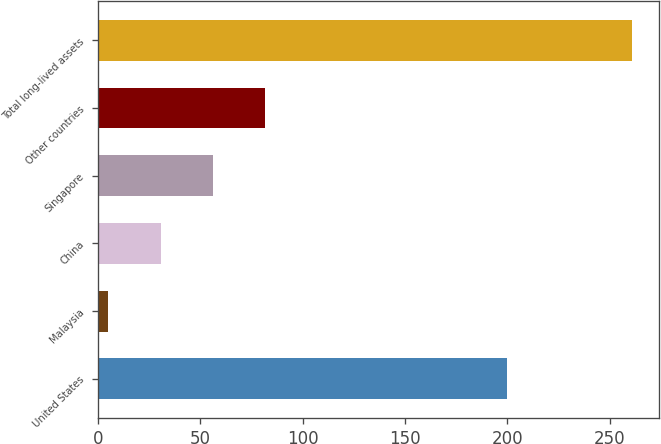Convert chart to OTSL. <chart><loc_0><loc_0><loc_500><loc_500><bar_chart><fcel>United States<fcel>Malaysia<fcel>China<fcel>Singapore<fcel>Other countries<fcel>Total long-lived assets<nl><fcel>200<fcel>5<fcel>30.6<fcel>56.2<fcel>81.8<fcel>261<nl></chart> 